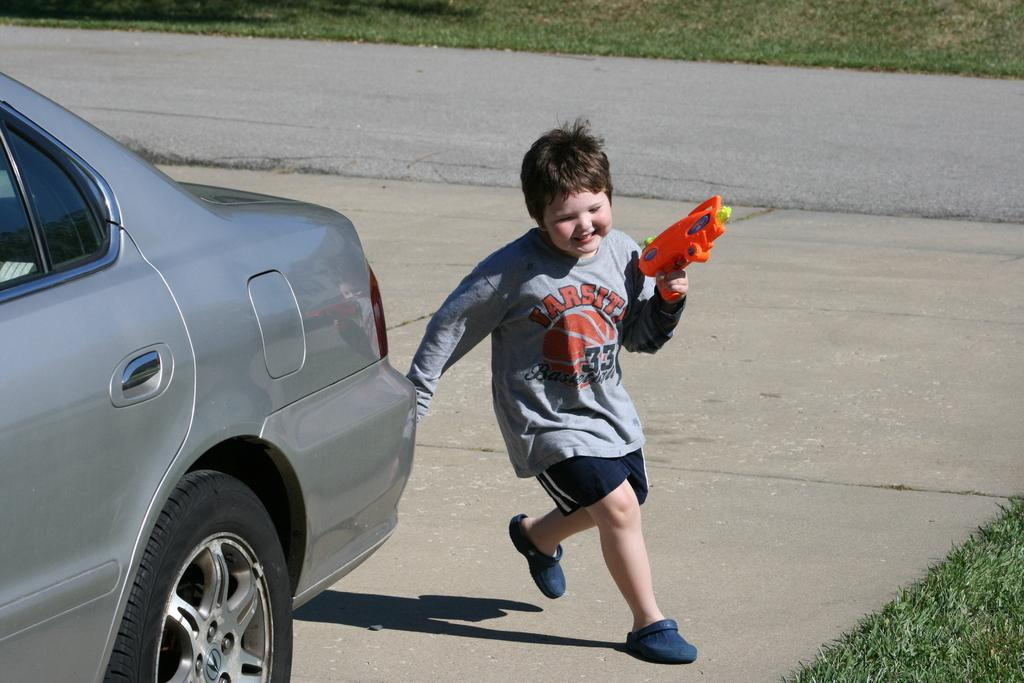What is the main subject of the image? The main subject of the image is a boy. What is the boy wearing? The boy is wearing a t-shirt, shorts, and shoes. What is the boy holding in the image? The boy is holding a plastic gun. What type of vehicle is visible in the image? There is a grey car in the image. What can be seen at the top of the image? There is a road and grass visible at the top of the image. What type of police car can be seen in the image? There is no police car present in the image. What happens when the drawer is opened in the image? There is no drawer present in the image. 